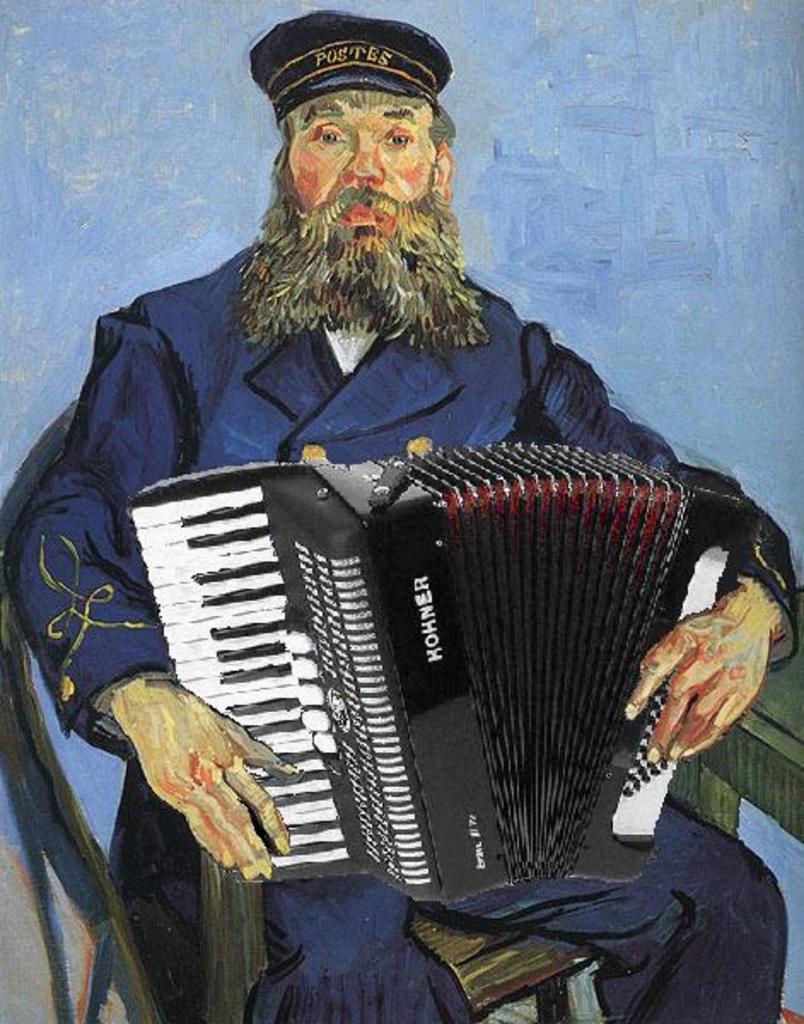How would you summarize this image in a sentence or two? In the image there is a painting of a man with a cap is sitting on the chair and holding an accordion. 